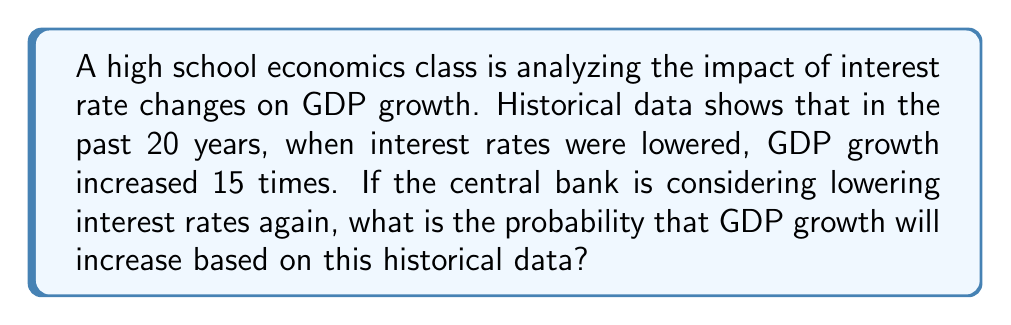Can you solve this math problem? To solve this problem, we'll use the classical definition of probability:

$$ P(A) = \frac{\text{Number of favorable outcomes}}{\text{Total number of possible outcomes}} $$

Step 1: Identify the number of favorable outcomes.
In this case, the number of times GDP growth increased when interest rates were lowered is 15.

Step 2: Identify the total number of possible outcomes.
The total number of observations is 20 (the past 20 years).

Step 3: Apply the probability formula.
$$ P(\text{GDP growth increases}) = \frac{15}{20} $$

Step 4: Simplify the fraction.
$$ P(\text{GDP growth increases}) = \frac{3}{4} = 0.75 $$

Therefore, based on the historical data, there is a 75% probability that GDP growth will increase if interest rates are lowered again.
Answer: $\frac{3}{4}$ or $0.75$ or $75\%$ 